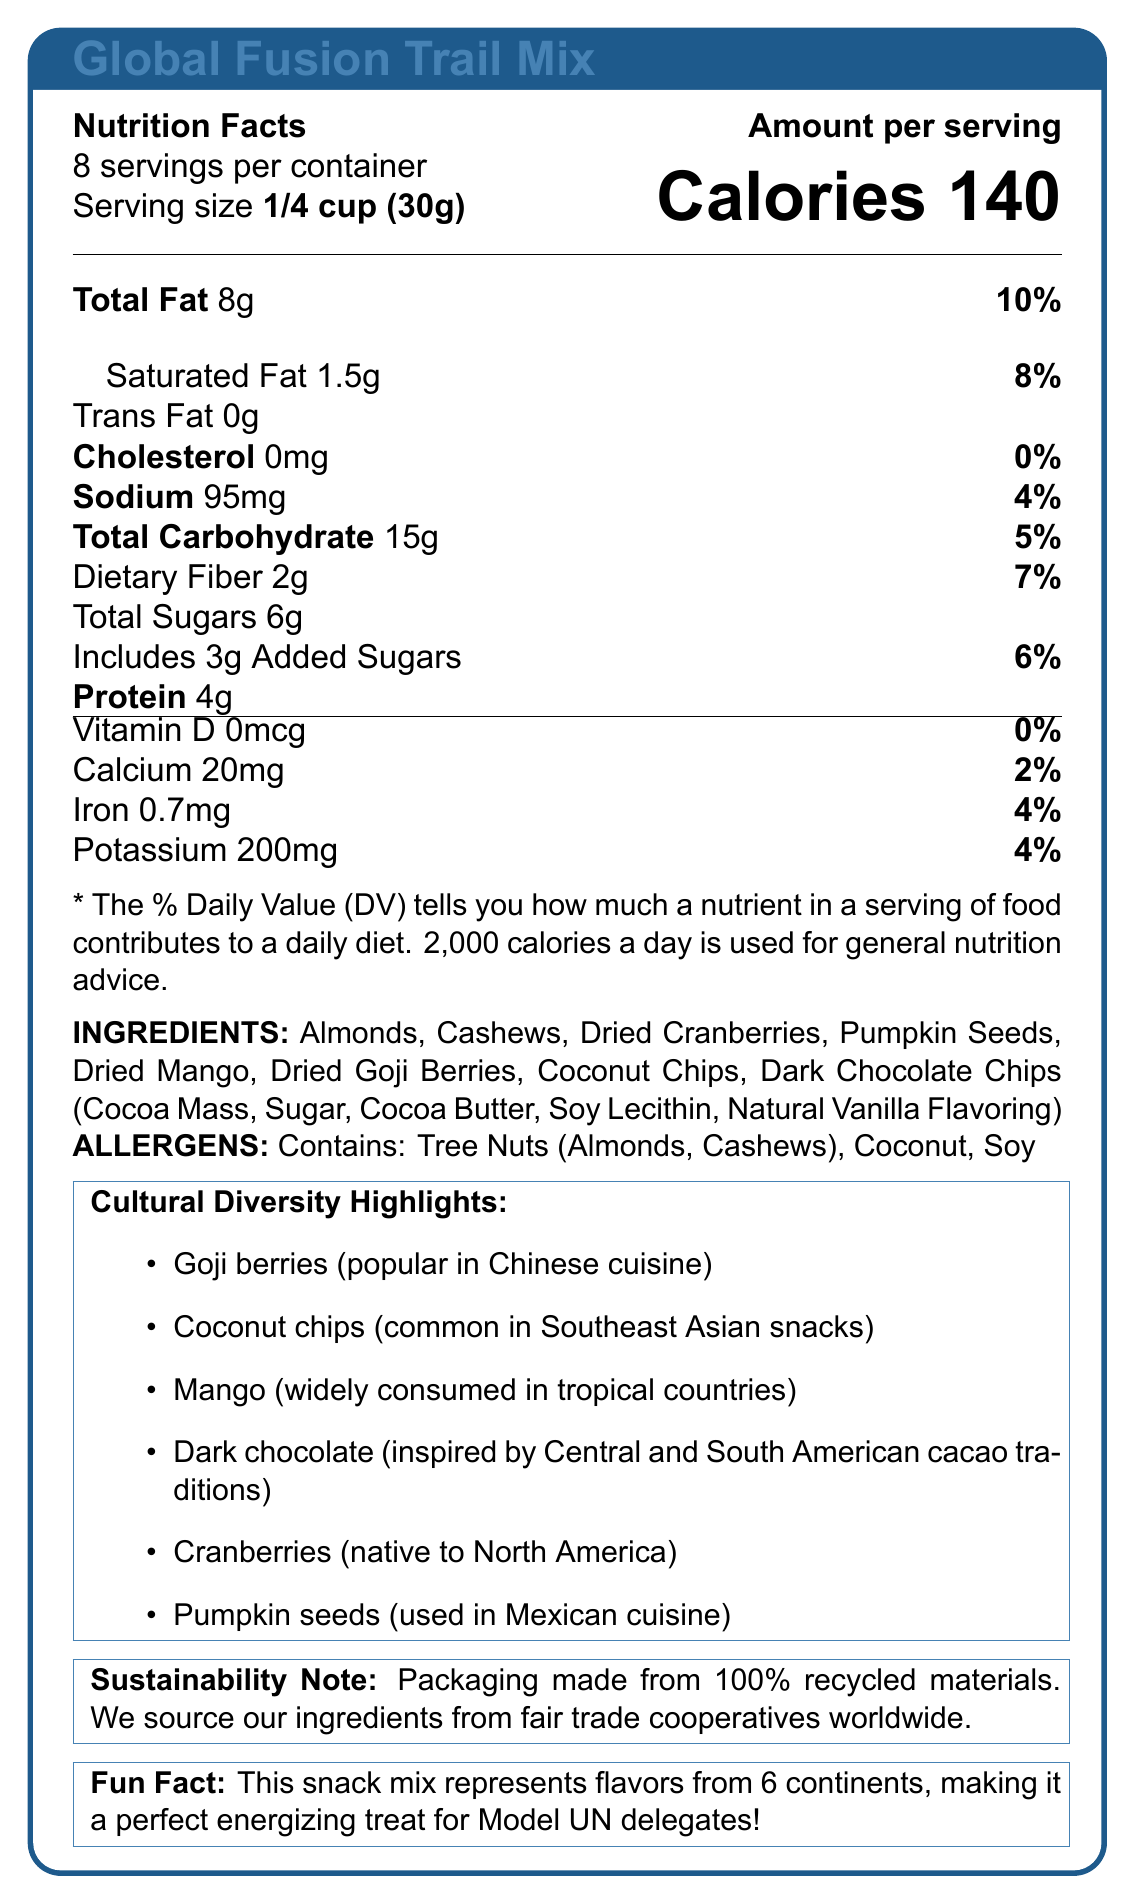what is the serving size? The document specifies that the serving size is 1/4 cup (30g).
Answer: 1/4 cup (30g) how many calories are there per serving? The document states that there are 140 calories per serving.
Answer: 140 how much total fat is in one serving? The total fat content per serving is indicated as 8g.
Answer: 8g are there any trans fats in the snack? The document states that trans fat content is 0g, meaning there are no trans fats in the snack.
Answer: No what is the main ingredient in the trail mix? The first ingredient listed is typically the main one, and in this case, it is Almonds.
Answer: Almonds is there any cholesterol in this snack? The document lists 0mg of cholesterol, indicating there is none in the snack.
Answer: No which nutrient is contributed the most as a percentage of daily value? A. Calcium B. Iron C. Total Fat D. Sodium The document states the daily value percentages, with Total Fat being the highest at 10%.
Answer: C. Total Fat which continent is represented by the goji berries? A. Europe B. Asia C. Africa D. North America The document mentions that goji berries are popular in Chinese cuisine, which is part of Asia.
Answer: B. Asia are there any allergens in the trail mix? The document lists that the snack contains tree nuts (almonds, cashews), coconut, and soy.
Answer: Yes which ingredient is commonly found in Southeast Asian snacks? The document mentions that coconut chips are common in Southeast Asian snacks.
Answer: Coconut chips how many servings are in one container? The document specifies that there are about 8 servings per container.
Answer: About 8 what is the fun fact about this snack mix? The document states that the snack mix represents flavors from 6 continents, making it a perfect snack for Model UN delegates.
Answer: It represents flavors from 6 continents. is any information provided about vitamin D in the trail mix? The document mentions Vitamin D, stating it's 0mcg and 0% daily value.
Answer: Yes describe the main idea of the document. The document provides comprehensive nutritional information for the Global Fusion Trail Mix, emphasizing its global ingredients, sustainable packaging, and suitability for Model UN delegates.
Answer: The document details the nutritional information of Global Fusion Trail Mix, including calories, fat, cholesterol, sodium, carbohydrates, protein, vitamins, and minerals. It also lists ingredients, allergens, cultural diversity highlights, a sustainability note, and a fun fact about the snack mix’s global representation. which ingredient is used in Mexican cuisine? The document mentions that pumpkin seeds are used in Mexican cuisine.
Answer: Pumpkin seeds where do the ingredients come from? The sustainability note mentions that ingredients are sourced from fair trade cooperatives worldwide.
Answer: Fair trade cooperatives worldwide can we determine the cost of one serving from the document? The document does not provide any information about the cost of the snack.
Answer: Not enough information how much protein is in a serving? The document lists 4g of protein per serving of the trail mix.
Answer: 4g does the packaging have any sustainability features? The document notes that the packaging is made from 100% recycled materials.
Answer: Yes 